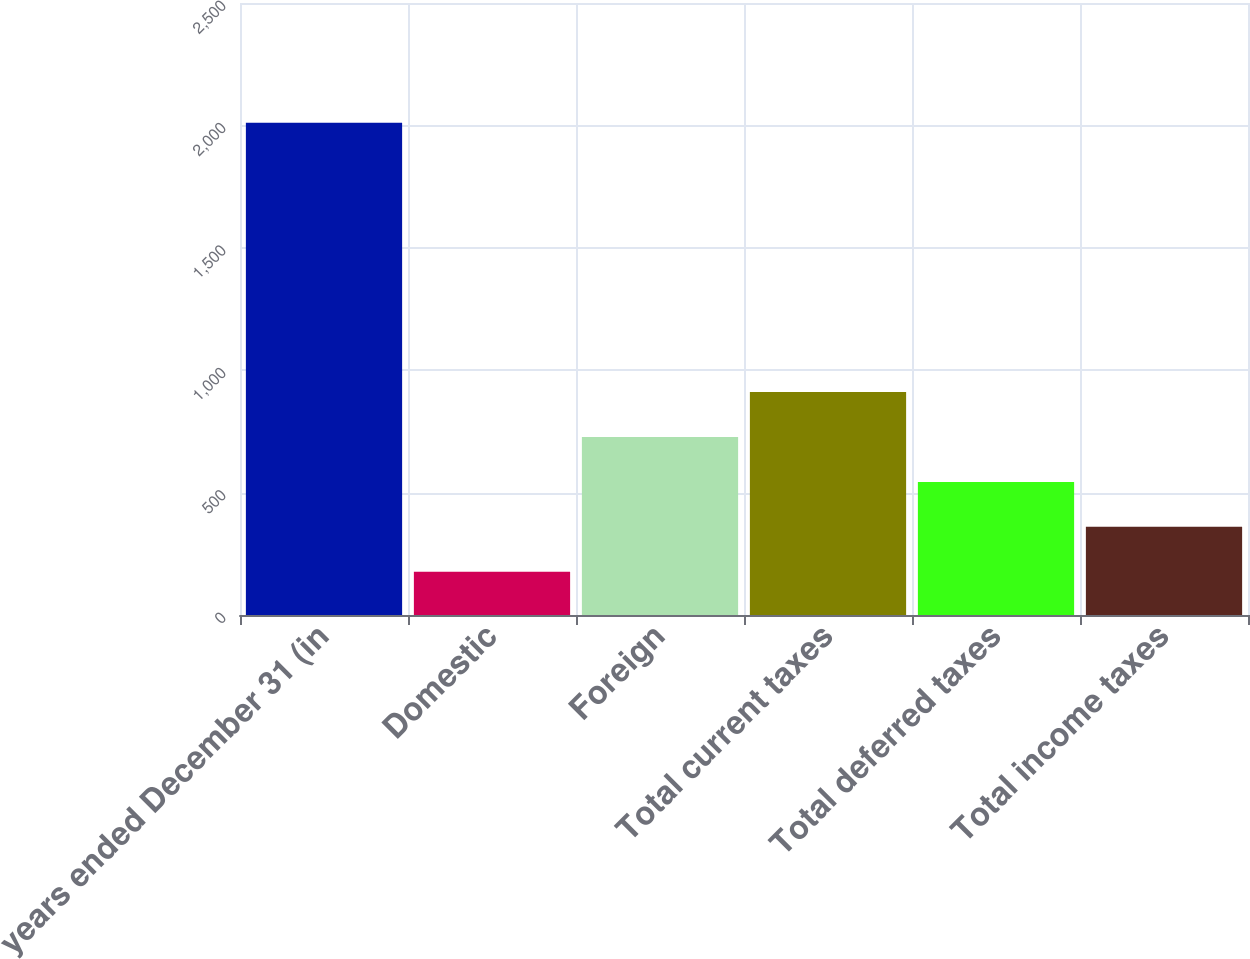Convert chart to OTSL. <chart><loc_0><loc_0><loc_500><loc_500><bar_chart><fcel>years ended December 31 (in<fcel>Domestic<fcel>Foreign<fcel>Total current taxes<fcel>Total deferred taxes<fcel>Total income taxes<nl><fcel>2011<fcel>177<fcel>727.2<fcel>910.6<fcel>543.8<fcel>360.4<nl></chart> 